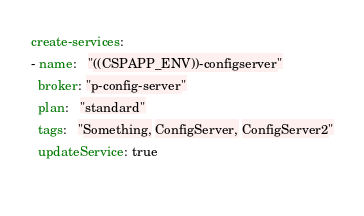<code> <loc_0><loc_0><loc_500><loc_500><_YAML_>create-services:
- name:   "((CSPAPP_ENV))-configserver"
  broker: "p-config-server"
  plan:   "standard"
  tags:   "Something, ConfigServer, ConfigServer2"
  updateService: true
  </code> 